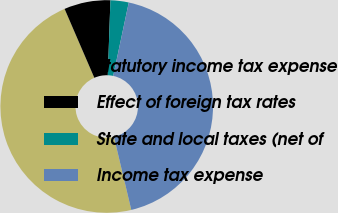Convert chart to OTSL. <chart><loc_0><loc_0><loc_500><loc_500><pie_chart><fcel>Statutory income tax expense<fcel>Effect of foreign tax rates<fcel>State and local taxes (net of<fcel>Income tax expense<nl><fcel>47.23%<fcel>7.04%<fcel>2.77%<fcel>42.96%<nl></chart> 